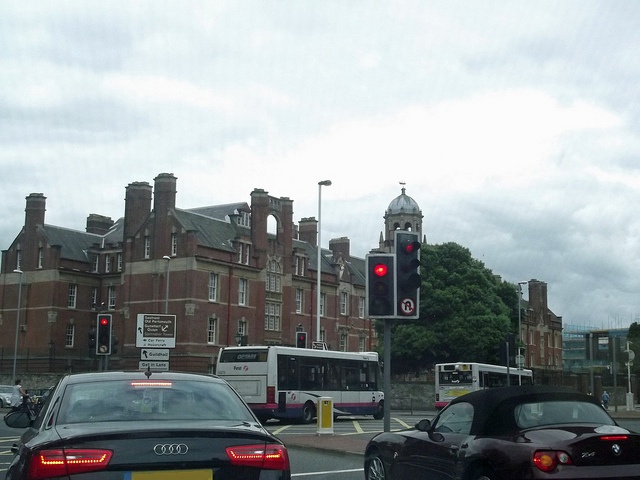Describe the objects in this image and their specific colors. I can see car in white, gray, black, and purple tones, car in white, black, gray, purple, and darkgray tones, bus in white, black, gray, and darkgray tones, traffic light in white, black, and gray tones, and bus in white, black, gray, and darkgray tones in this image. 